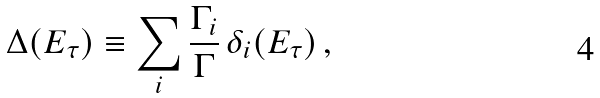Convert formula to latex. <formula><loc_0><loc_0><loc_500><loc_500>\Delta ( E _ { \tau } ) \equiv \sum _ { i } \frac { \Gamma _ { i } } { \Gamma } \, \delta _ { i } ( E _ { \tau } ) \, ,</formula> 